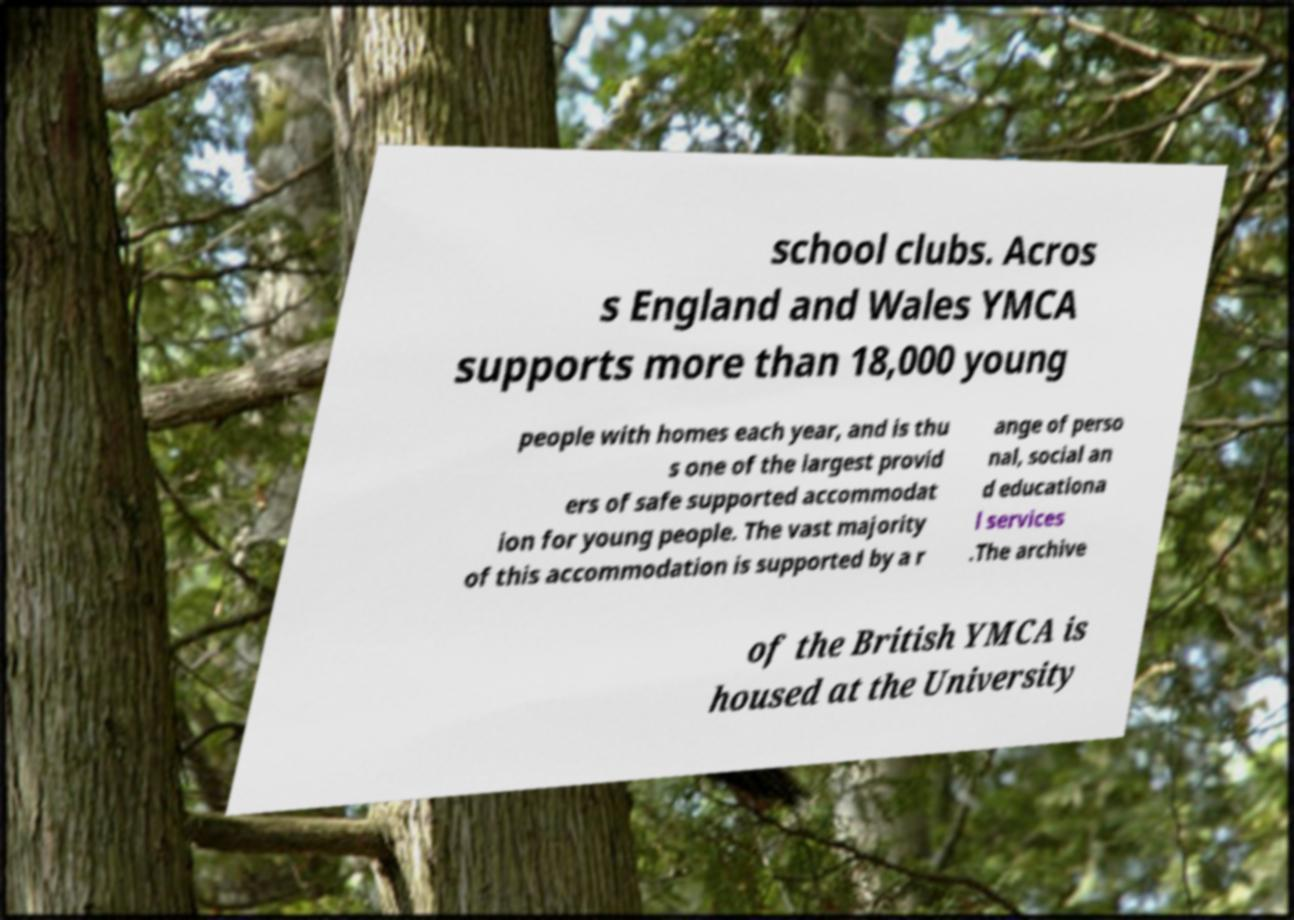There's text embedded in this image that I need extracted. Can you transcribe it verbatim? school clubs. Acros s England and Wales YMCA supports more than 18,000 young people with homes each year, and is thu s one of the largest provid ers of safe supported accommodat ion for young people. The vast majority of this accommodation is supported by a r ange of perso nal, social an d educationa l services .The archive of the British YMCA is housed at the University 